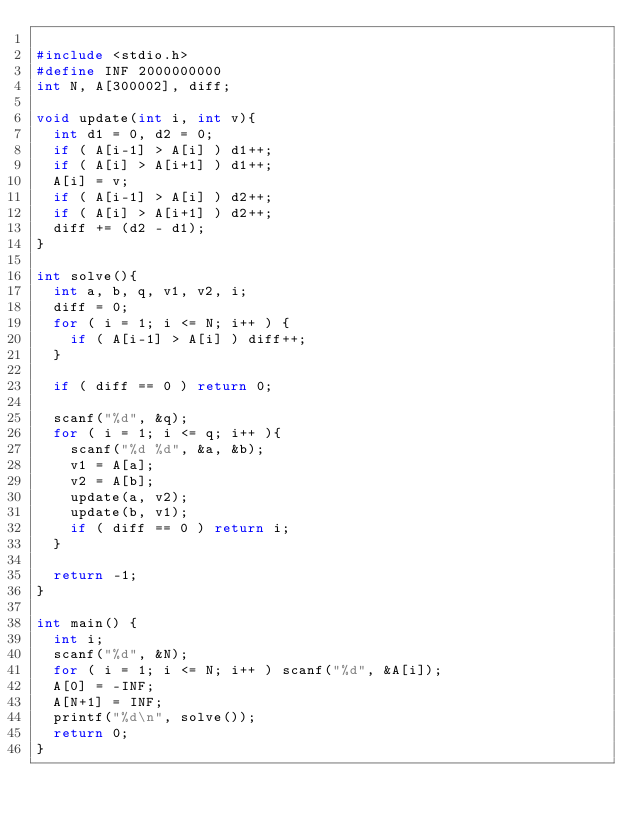Convert code to text. <code><loc_0><loc_0><loc_500><loc_500><_C_>
#include <stdio.h>
#define INF 2000000000
int N, A[300002], diff;

void update(int i, int v){
  int d1 = 0, d2 = 0;
  if ( A[i-1] > A[i] ) d1++;
  if ( A[i] > A[i+1] ) d1++;
  A[i] = v;
  if ( A[i-1] > A[i] ) d2++;
  if ( A[i] > A[i+1] ) d2++;
  diff += (d2 - d1);
}

int solve(){
  int a, b, q, v1, v2, i;
  diff = 0;
  for ( i = 1; i <= N; i++ ) {
    if ( A[i-1] > A[i] ) diff++;
  }

  if ( diff == 0 ) return 0;

  scanf("%d", &q);
  for ( i = 1; i <= q; i++ ){
    scanf("%d %d", &a, &b);
    v1 = A[a];
    v2 = A[b];
    update(a, v2);
    update(b, v1);
    if ( diff == 0 ) return i;
  }

  return -1;
}

int main() {
  int i;
  scanf("%d", &N);
  for ( i = 1; i <= N; i++ ) scanf("%d", &A[i]);
  A[0] = -INF;
  A[N+1] = INF;
  printf("%d\n", solve());
  return 0;
}
</code> 